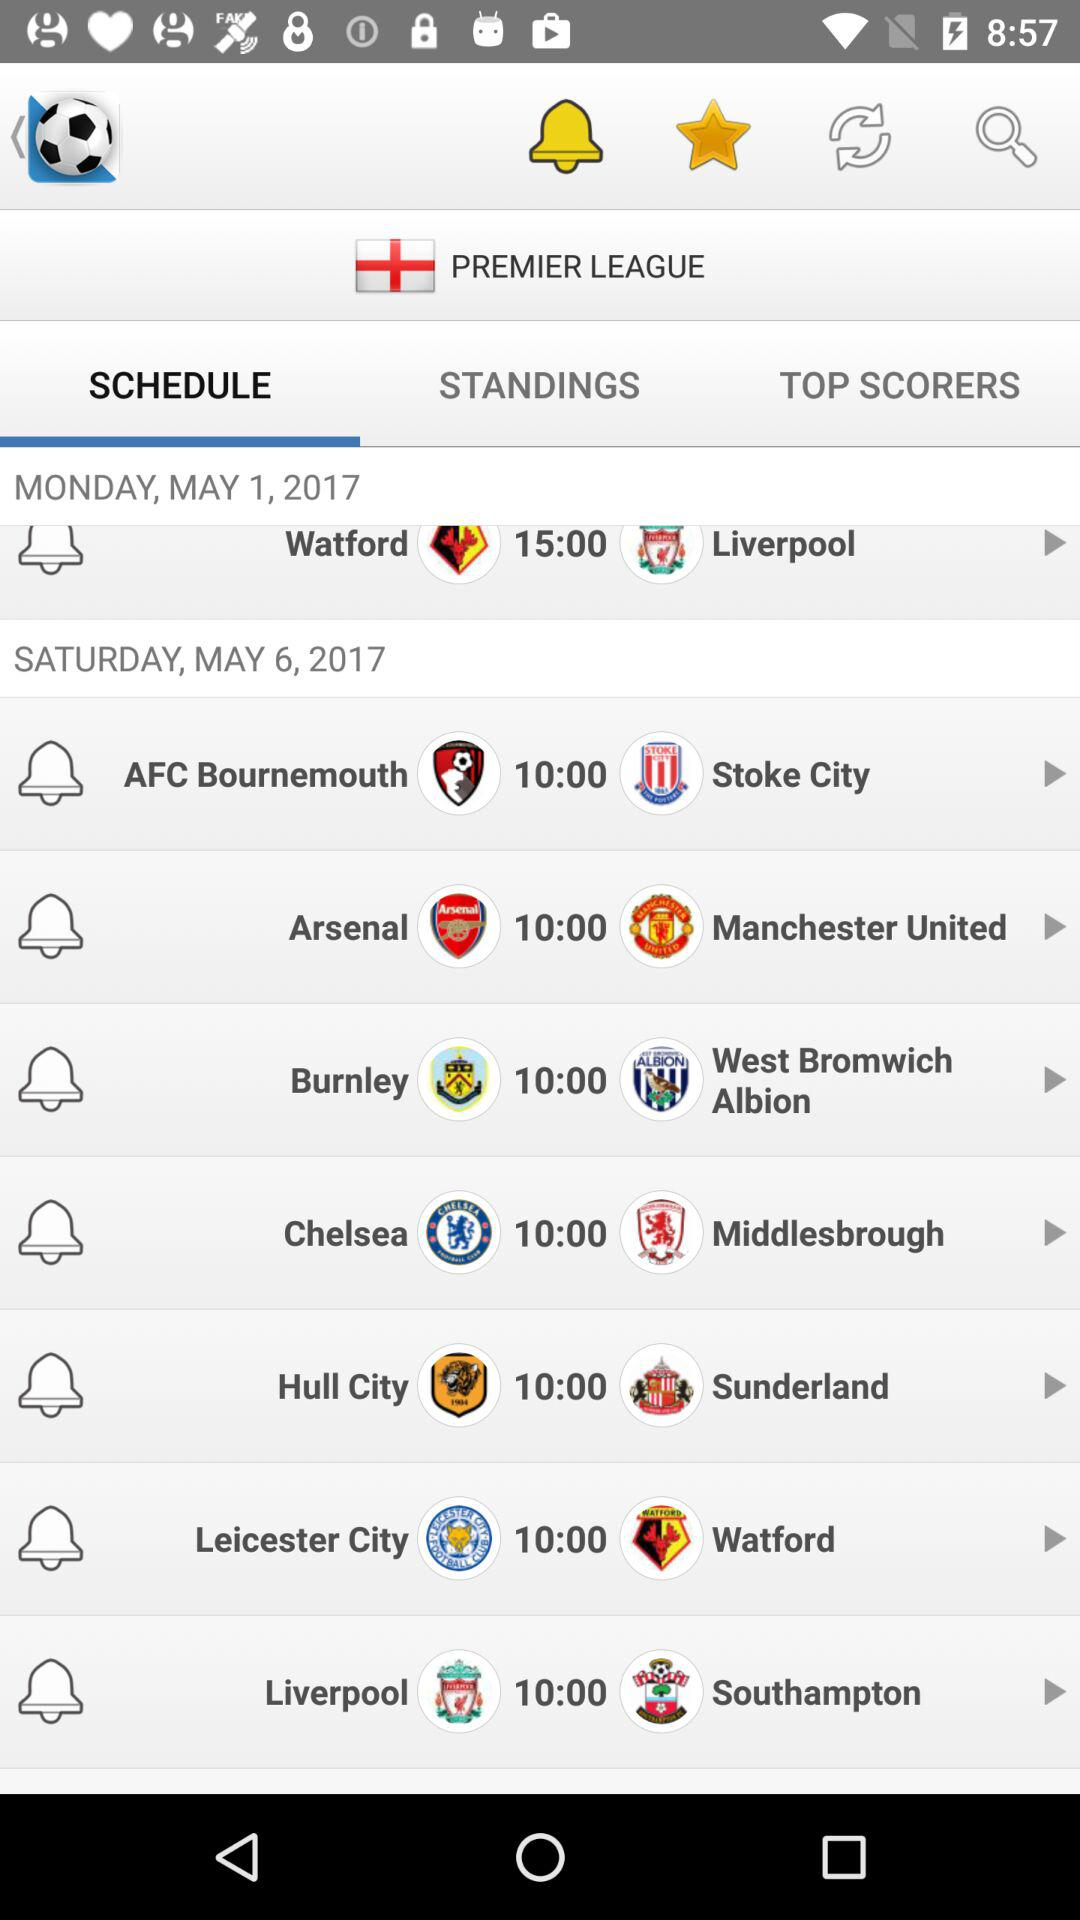Which tab is selected? The selected tab is "SCHEDULE". 